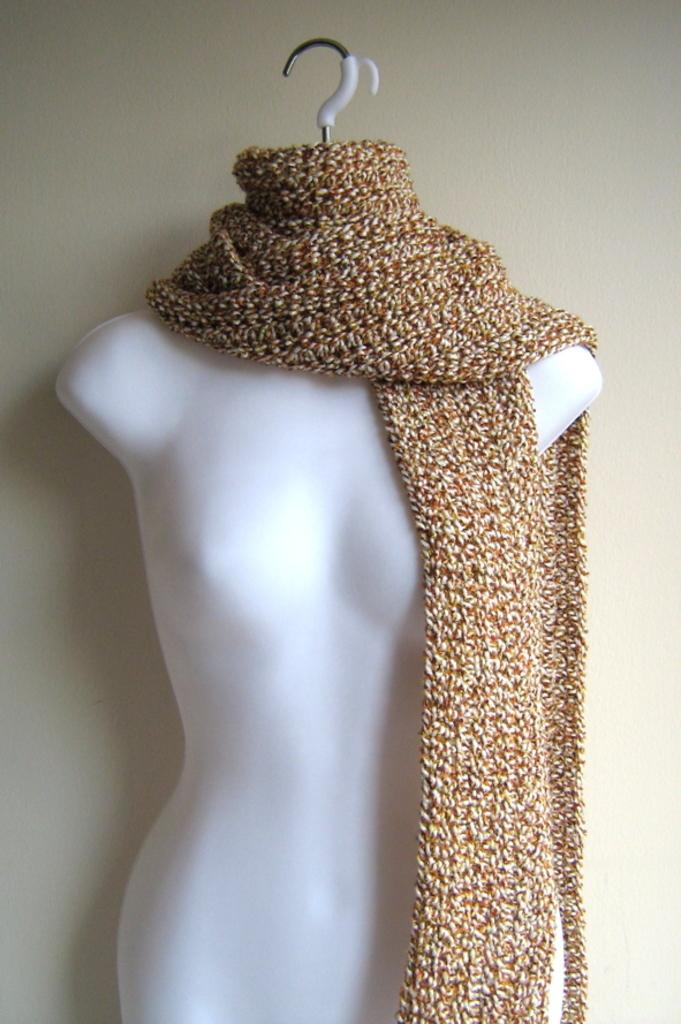What is the main subject in the picture? There is a mannequin in the picture. What is placed on the mannequin? The mannequin has a cloth placed on it. What type of frog can be seen in the scene? There is no frog present in the image, and therefore no such scene can be observed. 